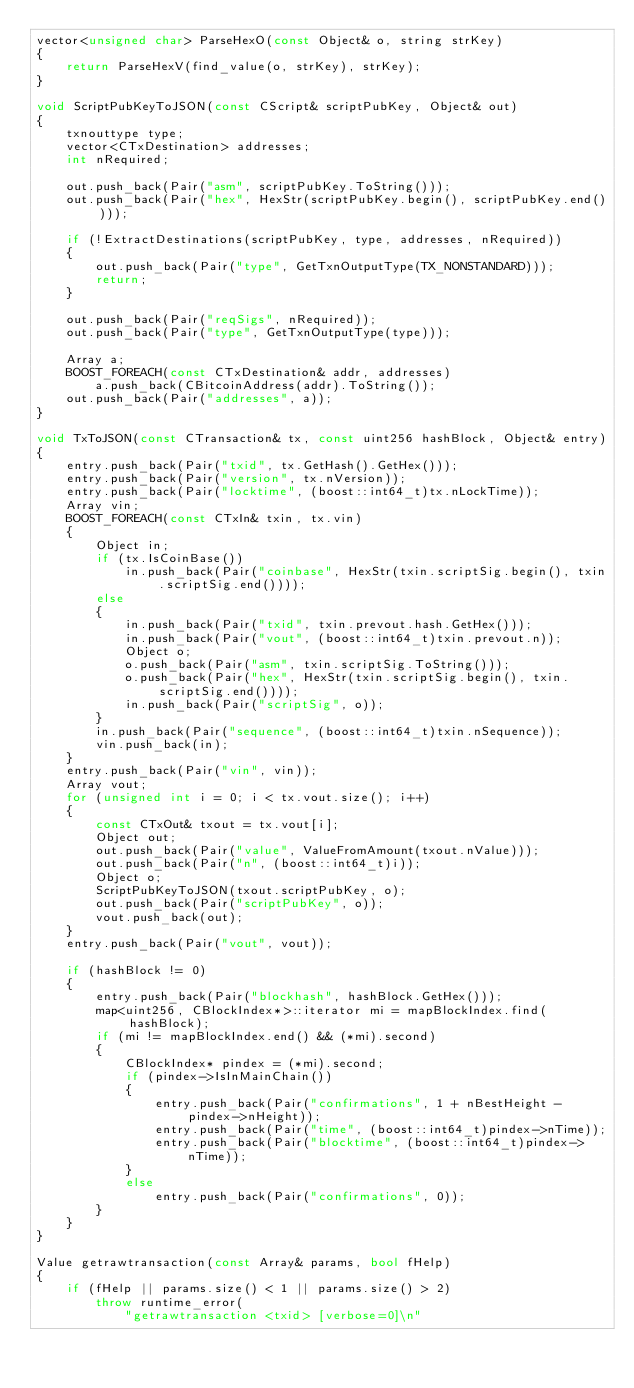Convert code to text. <code><loc_0><loc_0><loc_500><loc_500><_C++_>vector<unsigned char> ParseHexO(const Object& o, string strKey)
{
    return ParseHexV(find_value(o, strKey), strKey);
}

void ScriptPubKeyToJSON(const CScript& scriptPubKey, Object& out)
{
    txnouttype type;
    vector<CTxDestination> addresses;
    int nRequired;

    out.push_back(Pair("asm", scriptPubKey.ToString()));
    out.push_back(Pair("hex", HexStr(scriptPubKey.begin(), scriptPubKey.end())));

    if (!ExtractDestinations(scriptPubKey, type, addresses, nRequired))
    {
        out.push_back(Pair("type", GetTxnOutputType(TX_NONSTANDARD)));
        return;
    }

    out.push_back(Pair("reqSigs", nRequired));
    out.push_back(Pair("type", GetTxnOutputType(type)));

    Array a;
    BOOST_FOREACH(const CTxDestination& addr, addresses)
        a.push_back(CBitcoinAddress(addr).ToString());
    out.push_back(Pair("addresses", a));
}

void TxToJSON(const CTransaction& tx, const uint256 hashBlock, Object& entry)
{
    entry.push_back(Pair("txid", tx.GetHash().GetHex()));
    entry.push_back(Pair("version", tx.nVersion));
    entry.push_back(Pair("locktime", (boost::int64_t)tx.nLockTime));
    Array vin;
    BOOST_FOREACH(const CTxIn& txin, tx.vin)
    {
        Object in;
        if (tx.IsCoinBase())
            in.push_back(Pair("coinbase", HexStr(txin.scriptSig.begin(), txin.scriptSig.end())));
        else
        {
            in.push_back(Pair("txid", txin.prevout.hash.GetHex()));
            in.push_back(Pair("vout", (boost::int64_t)txin.prevout.n));
            Object o;
            o.push_back(Pair("asm", txin.scriptSig.ToString()));
            o.push_back(Pair("hex", HexStr(txin.scriptSig.begin(), txin.scriptSig.end())));
            in.push_back(Pair("scriptSig", o));
        }
        in.push_back(Pair("sequence", (boost::int64_t)txin.nSequence));
        vin.push_back(in);
    }
    entry.push_back(Pair("vin", vin));
    Array vout;
    for (unsigned int i = 0; i < tx.vout.size(); i++)
    {
        const CTxOut& txout = tx.vout[i];
        Object out;
        out.push_back(Pair("value", ValueFromAmount(txout.nValue)));
        out.push_back(Pair("n", (boost::int64_t)i));
        Object o;
        ScriptPubKeyToJSON(txout.scriptPubKey, o);
        out.push_back(Pair("scriptPubKey", o));
        vout.push_back(out);
    }
    entry.push_back(Pair("vout", vout));

    if (hashBlock != 0)
    {
        entry.push_back(Pair("blockhash", hashBlock.GetHex()));
        map<uint256, CBlockIndex*>::iterator mi = mapBlockIndex.find(hashBlock);
        if (mi != mapBlockIndex.end() && (*mi).second)
        {
            CBlockIndex* pindex = (*mi).second;
            if (pindex->IsInMainChain())
            {
                entry.push_back(Pair("confirmations", 1 + nBestHeight - pindex->nHeight));
                entry.push_back(Pair("time", (boost::int64_t)pindex->nTime));
                entry.push_back(Pair("blocktime", (boost::int64_t)pindex->nTime));
            }
            else
                entry.push_back(Pair("confirmations", 0));
        }
    }
}

Value getrawtransaction(const Array& params, bool fHelp)
{
    if (fHelp || params.size() < 1 || params.size() > 2)
        throw runtime_error(
            "getrawtransaction <txid> [verbose=0]\n"</code> 